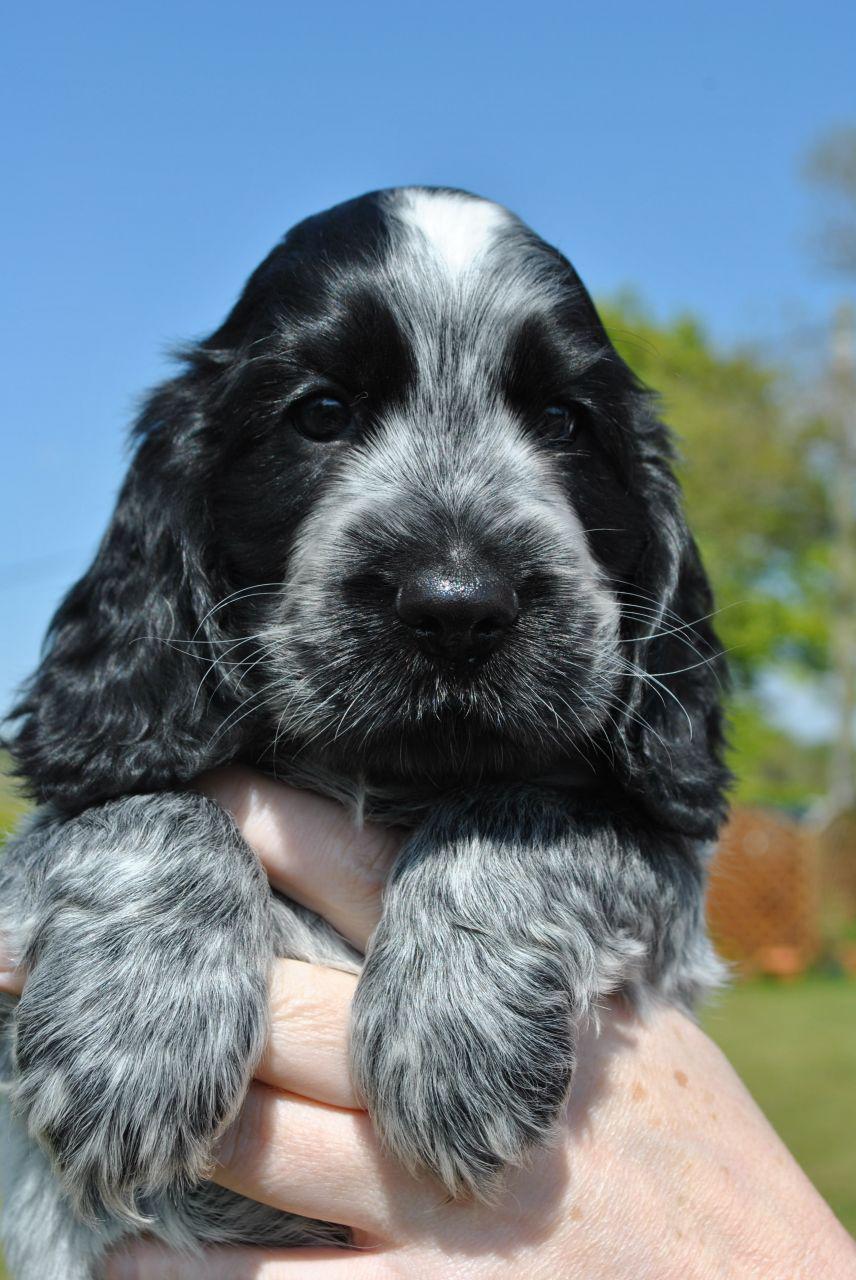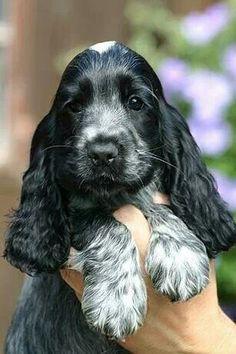The first image is the image on the left, the second image is the image on the right. Given the left and right images, does the statement "the right pic has human shoes in it" hold true? Answer yes or no. No. The first image is the image on the left, the second image is the image on the right. Examine the images to the left and right. Is the description "At least one dog is being held in someone's hands." accurate? Answer yes or no. Yes. 